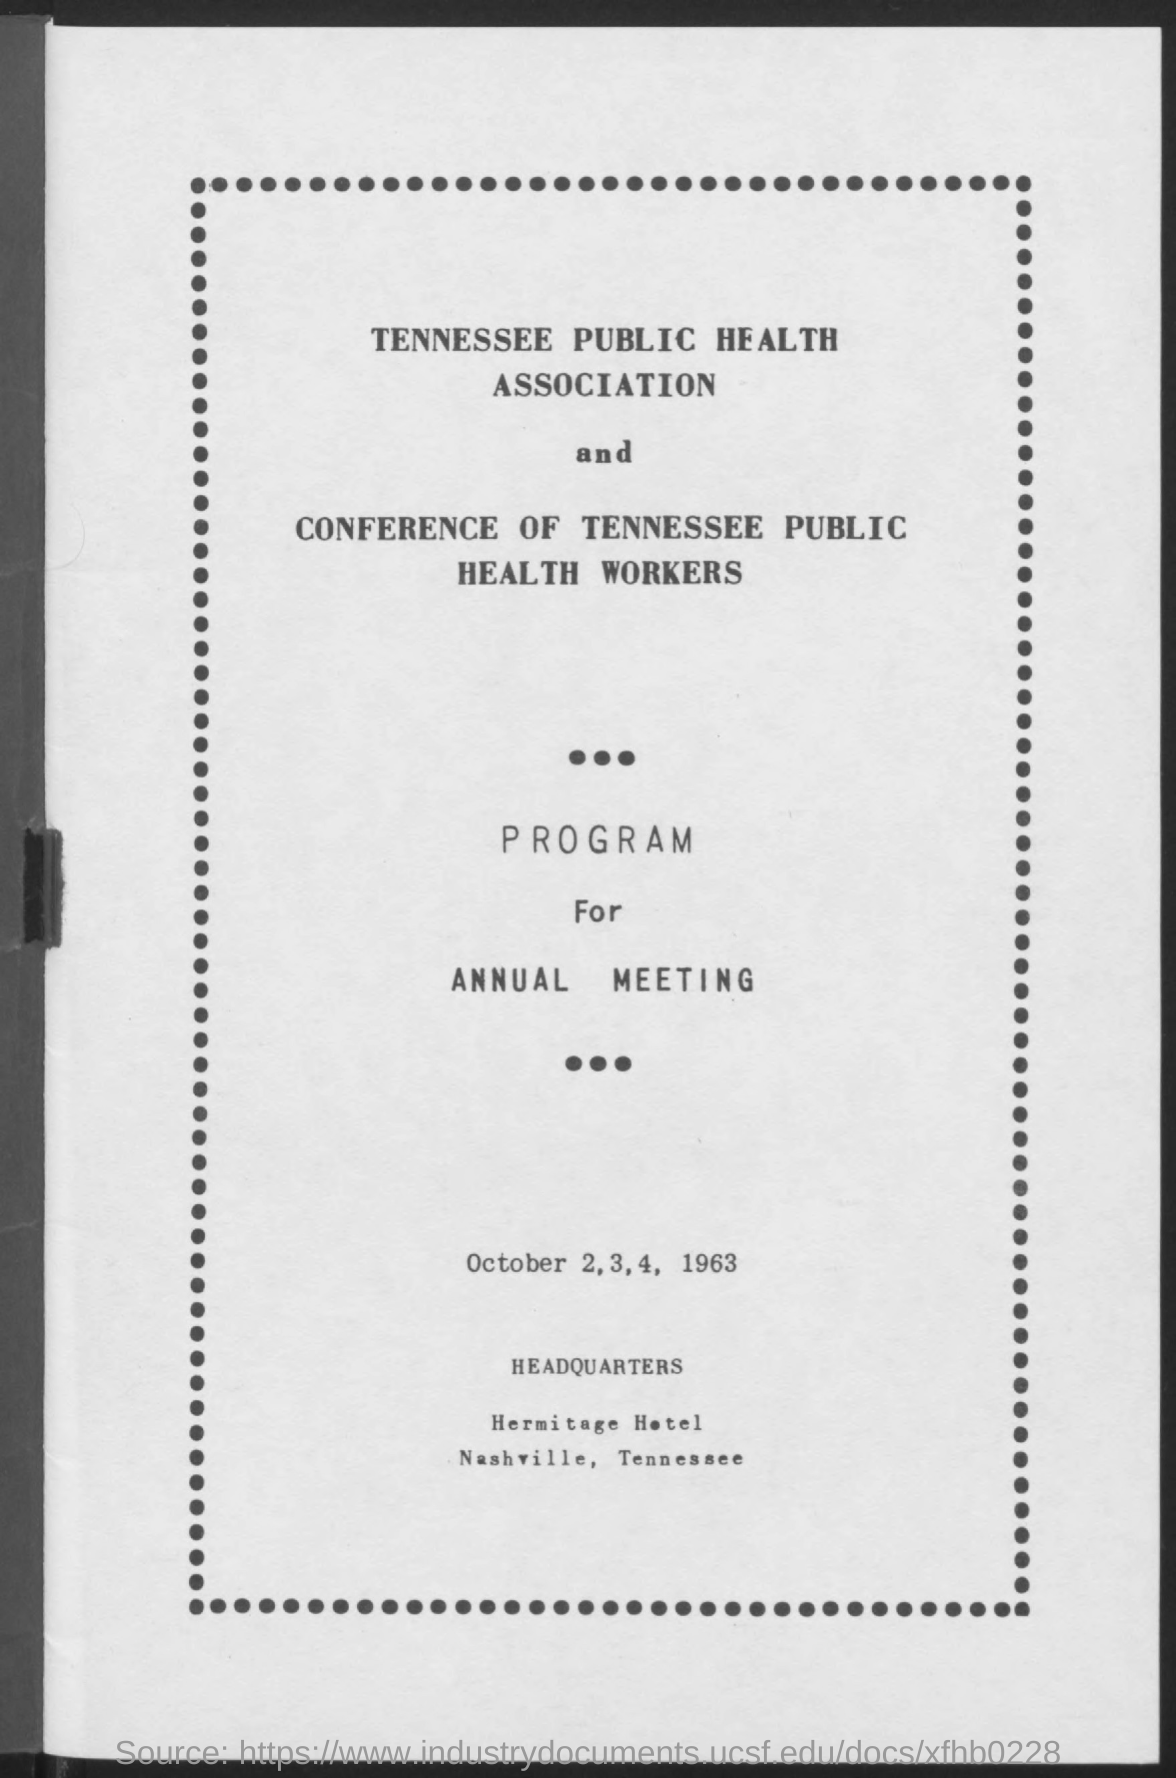When is the annual meeting?
Your answer should be compact. October 2,3,4, 1963. Where is it held?
Your response must be concise. Hermitage Hotel  Nashville, Tennessee. 